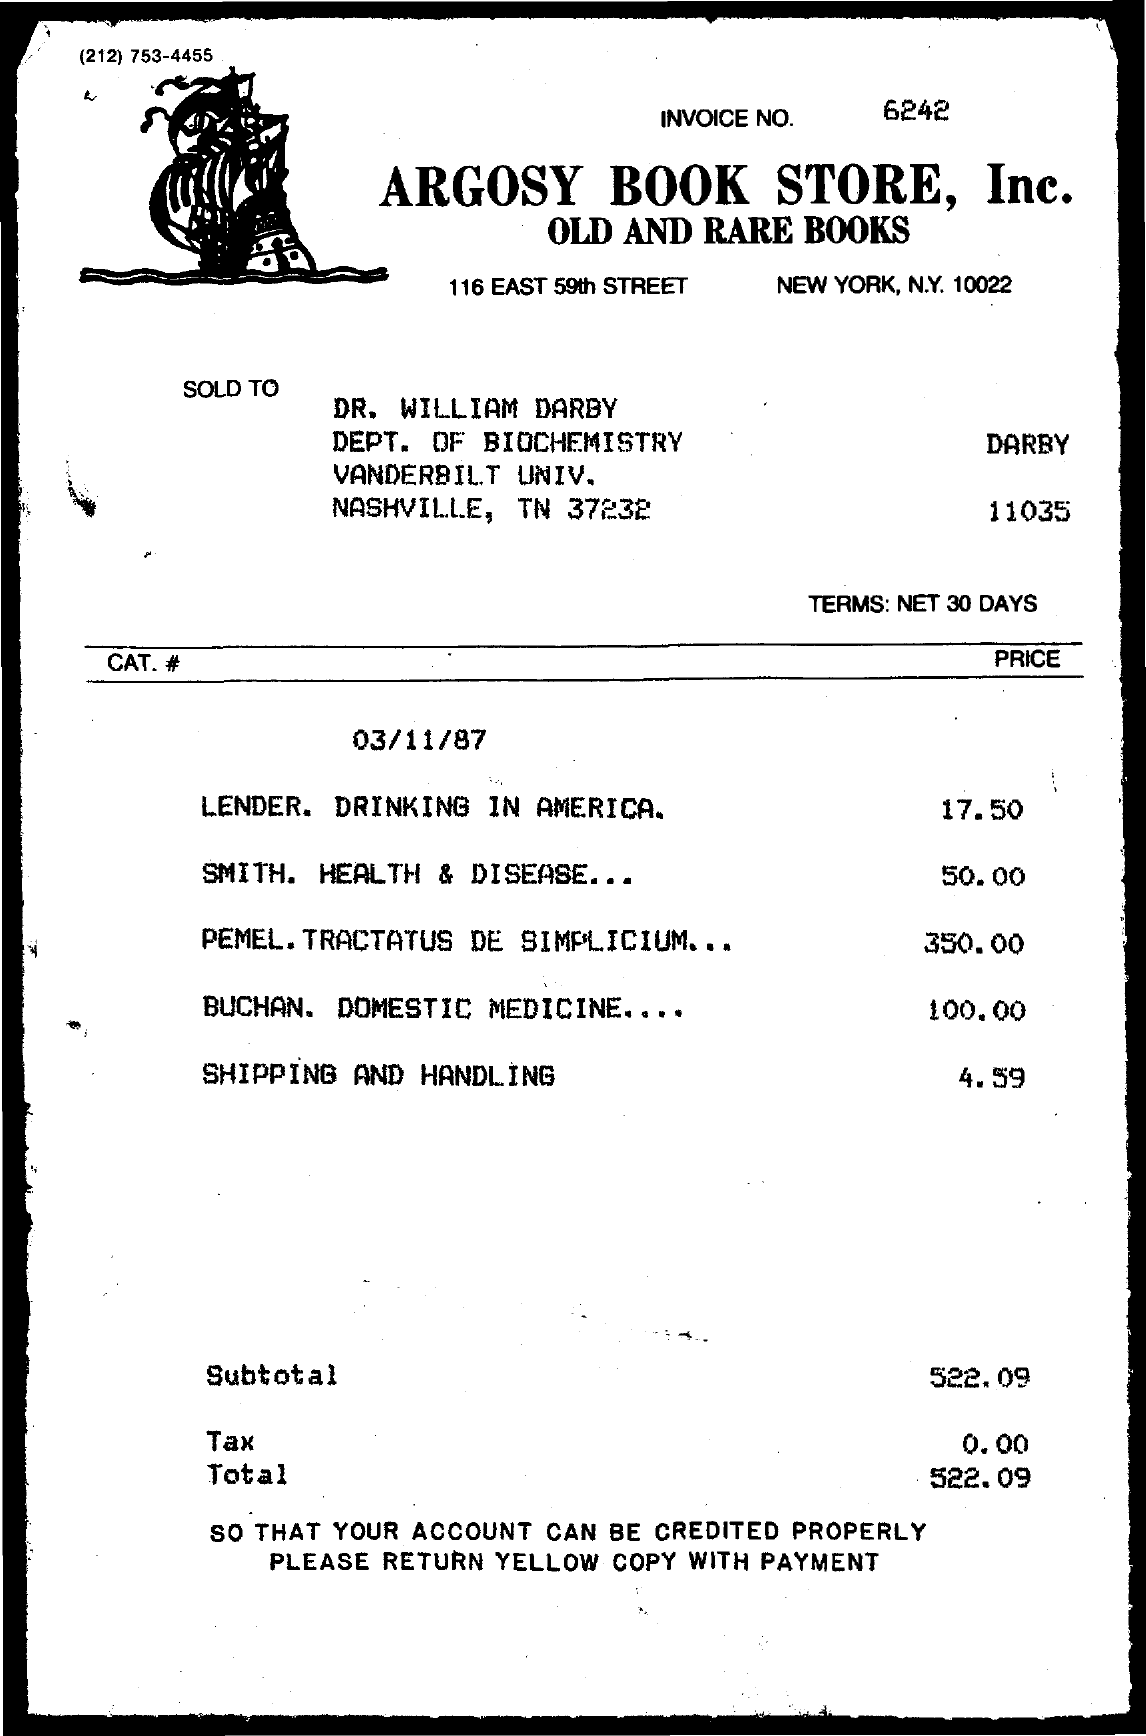What is invoice no.?
Offer a terse response. 6242. What is the name of book store?
Offer a terse response. Argosy Book Store, Inc. What is the address of argosy book store, inc. ?
Offer a terse response. 116 East 59th Street. What is the subtotal?
Provide a succinct answer. 522.09. What is the amount charged for shipping and handling?
Your response must be concise. $4.59. What is cost of smith. health & disease.. ?
Provide a short and direct response. 50.00. 